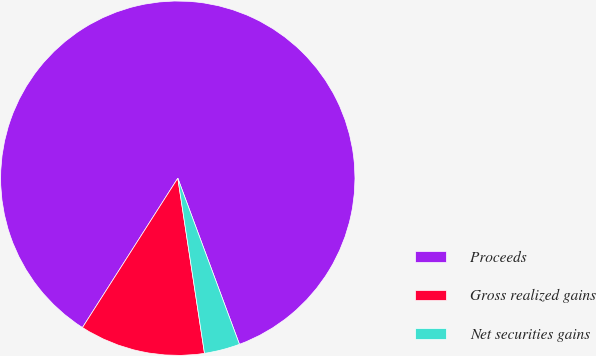Convert chart to OTSL. <chart><loc_0><loc_0><loc_500><loc_500><pie_chart><fcel>Proceeds<fcel>Gross realized gains<fcel>Net securities gains<nl><fcel>85.3%<fcel>11.45%<fcel>3.25%<nl></chart> 